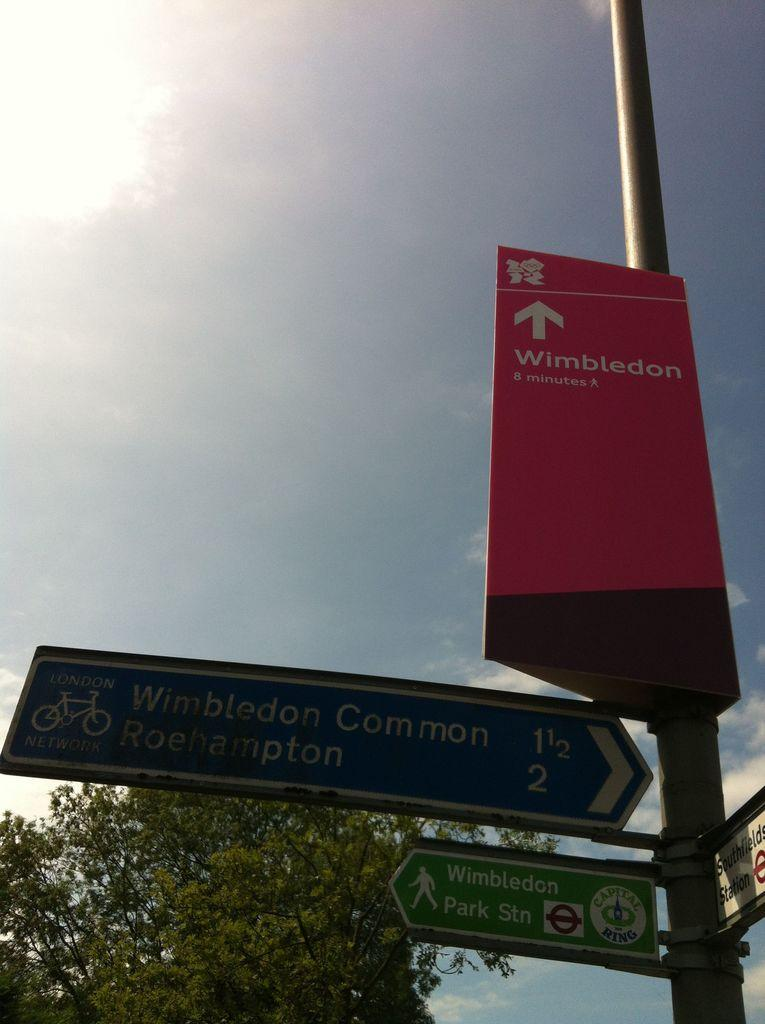What is the main object in the image? There is a pole in the image. What is attached to the pole? There is a caution board and other boards attached to the pole. What can be seen in the background of the image? There is a tree in the background of the image. How many pizzas are being delivered to the pole in the image? There are no pizzas or delivery mentioned in the image; it only features a pole with attached boards and a tree in the background. 